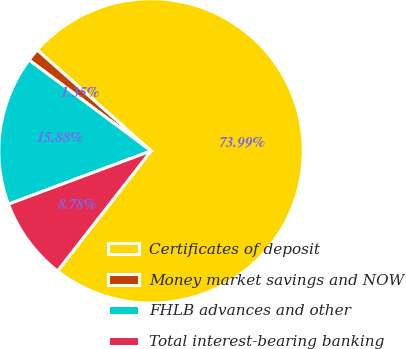<chart> <loc_0><loc_0><loc_500><loc_500><pie_chart><fcel>Certificates of deposit<fcel>Money market savings and NOW<fcel>FHLB advances and other<fcel>Total interest-bearing banking<nl><fcel>73.99%<fcel>1.35%<fcel>15.88%<fcel>8.78%<nl></chart> 